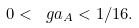<formula> <loc_0><loc_0><loc_500><loc_500>0 < \ g a _ { A } < 1 / 1 6 .</formula> 